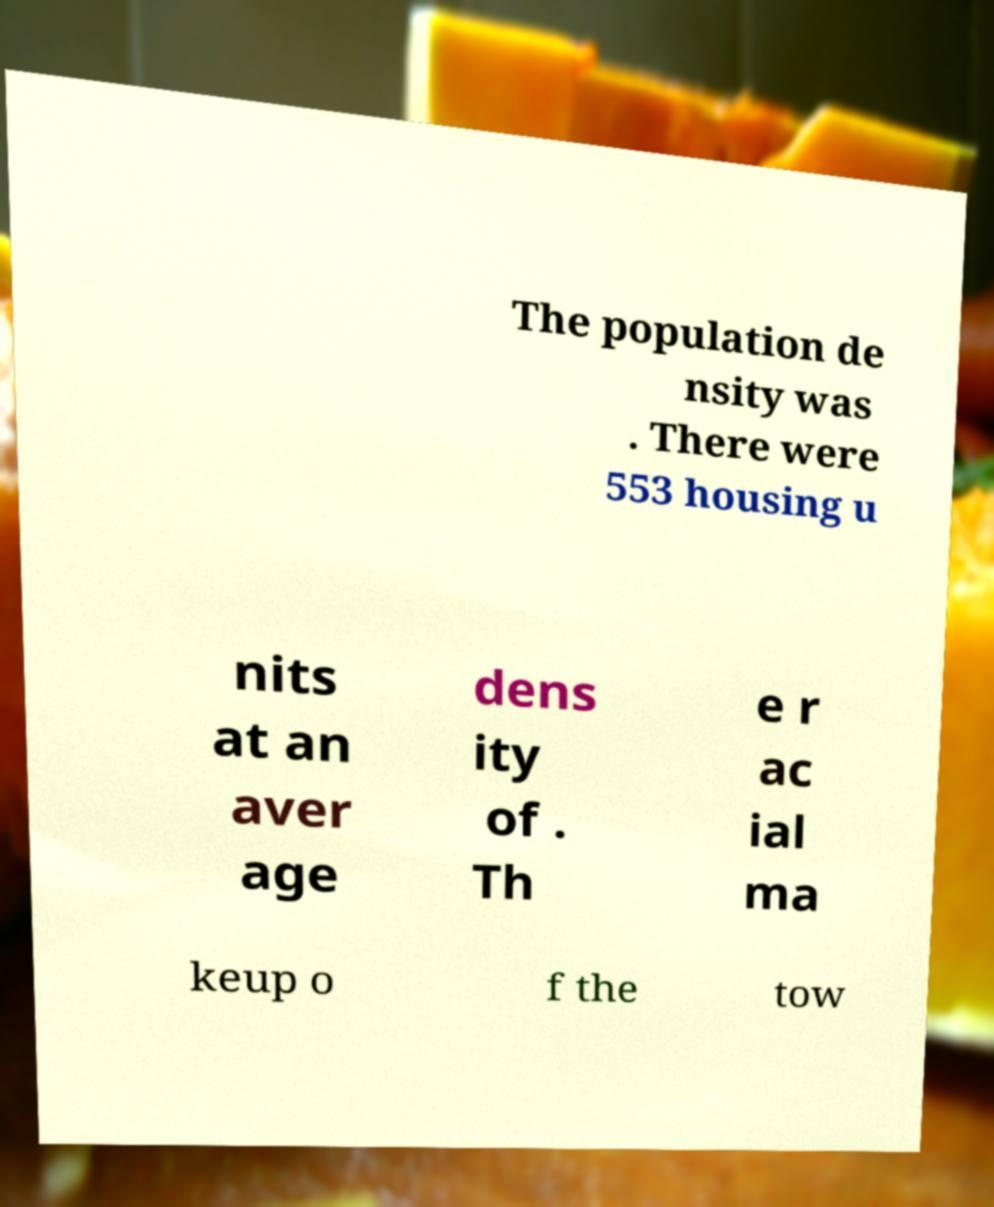For documentation purposes, I need the text within this image transcribed. Could you provide that? The population de nsity was . There were 553 housing u nits at an aver age dens ity of . Th e r ac ial ma keup o f the tow 